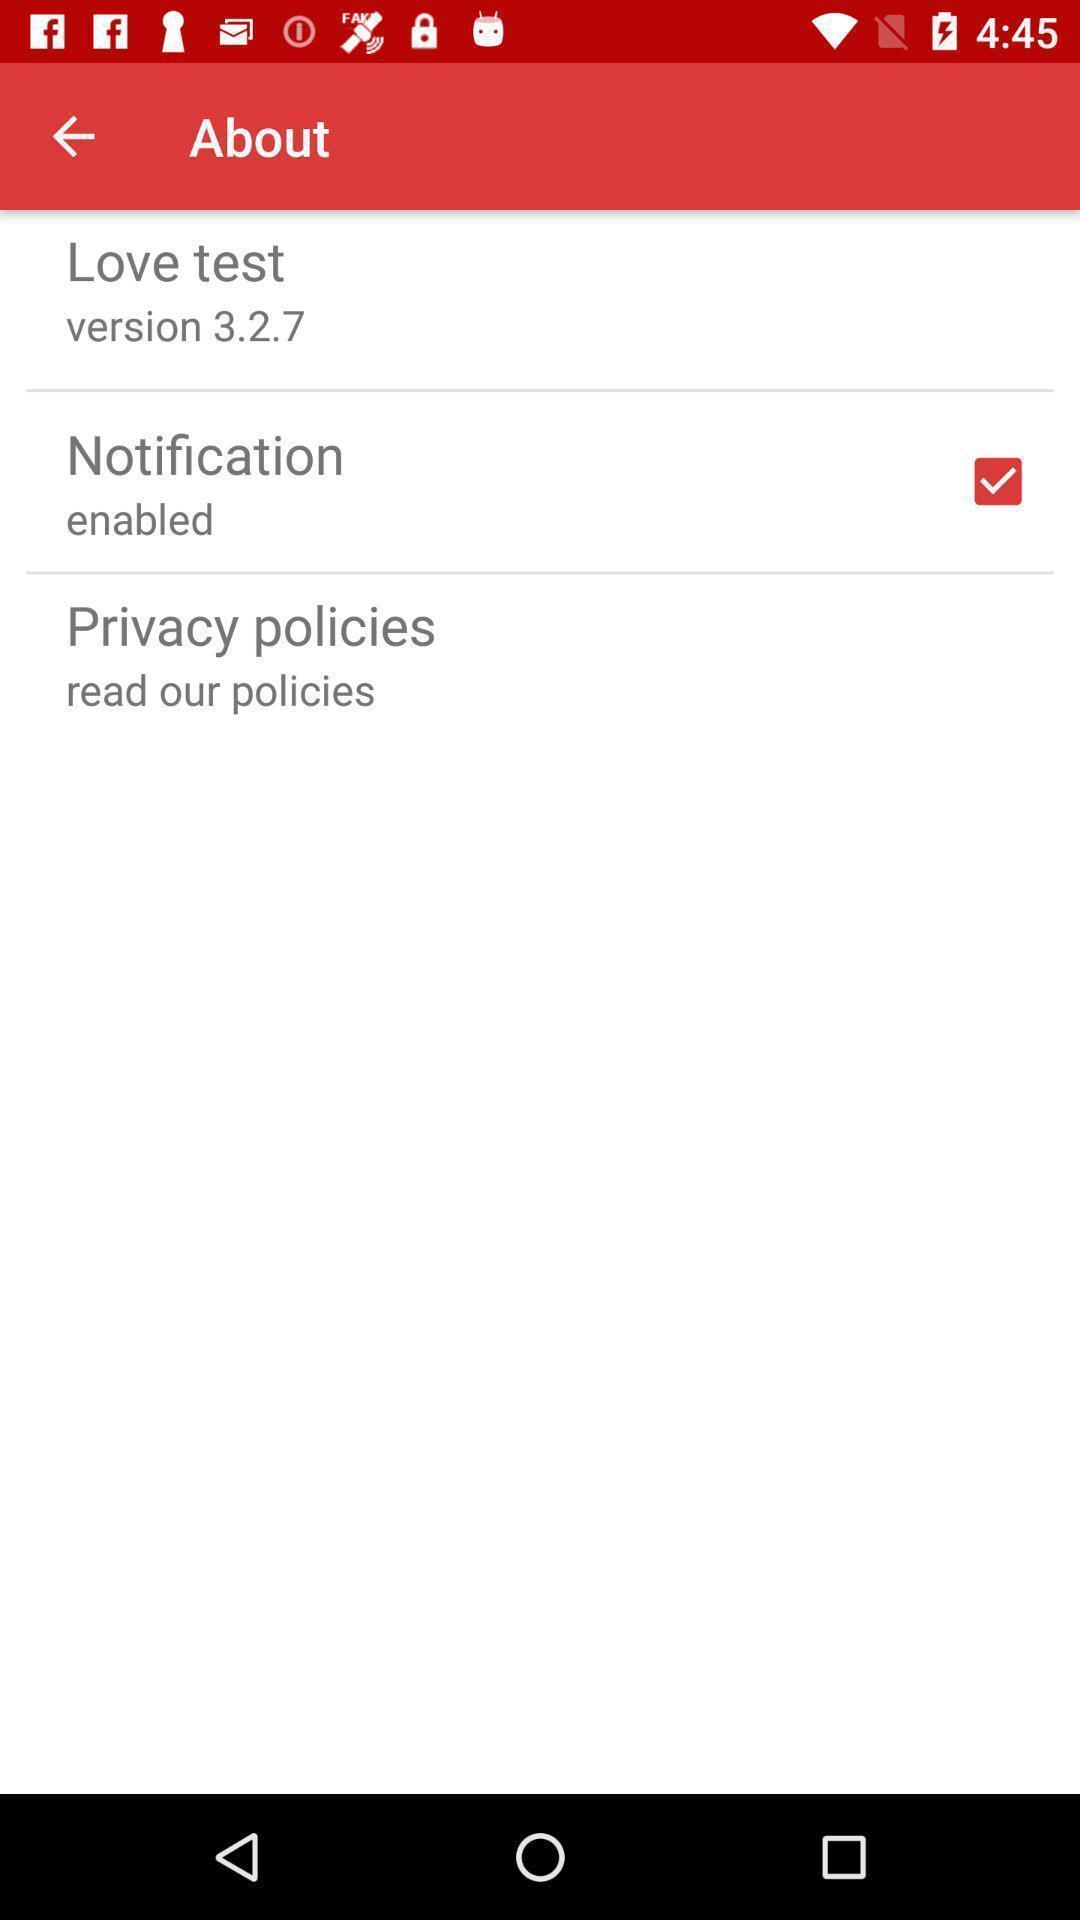What details can you identify in this image? Screen shows about details. 